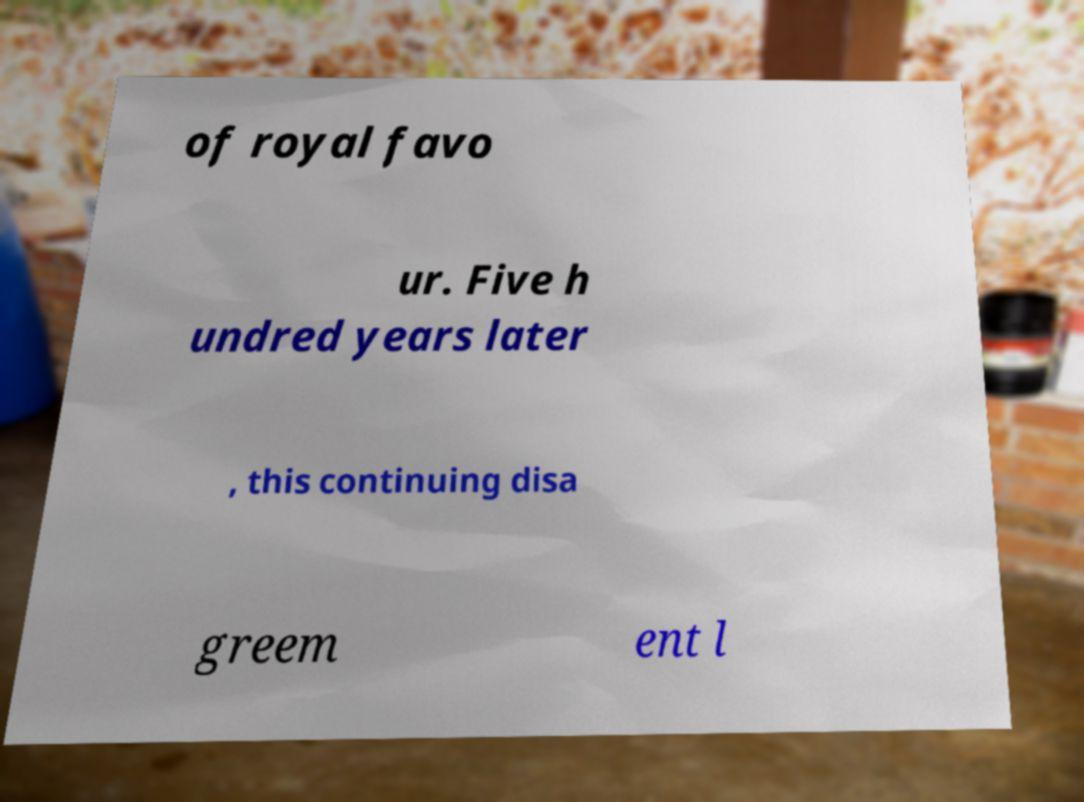For documentation purposes, I need the text within this image transcribed. Could you provide that? of royal favo ur. Five h undred years later , this continuing disa greem ent l 